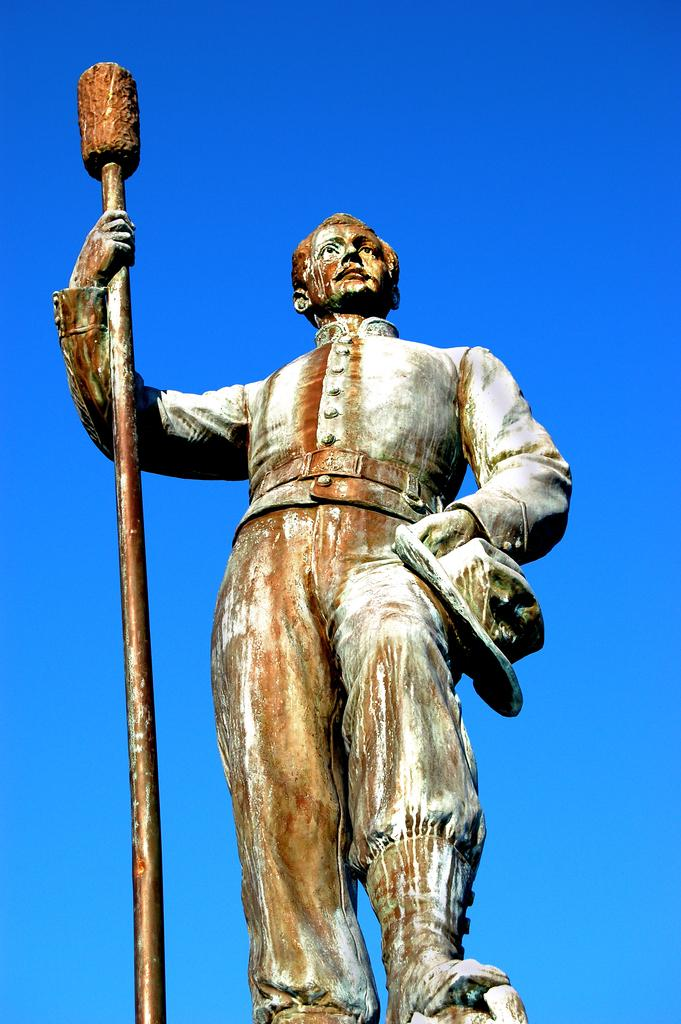What is the main subject of the image? There is a statue of a person in the image. What can be seen in the background of the image? The sky is visible in the background of the image. What scent can be detected from the statue in the image? There is no scent associated with the statue in the image, as it is a sculpture made of inanimate material. 